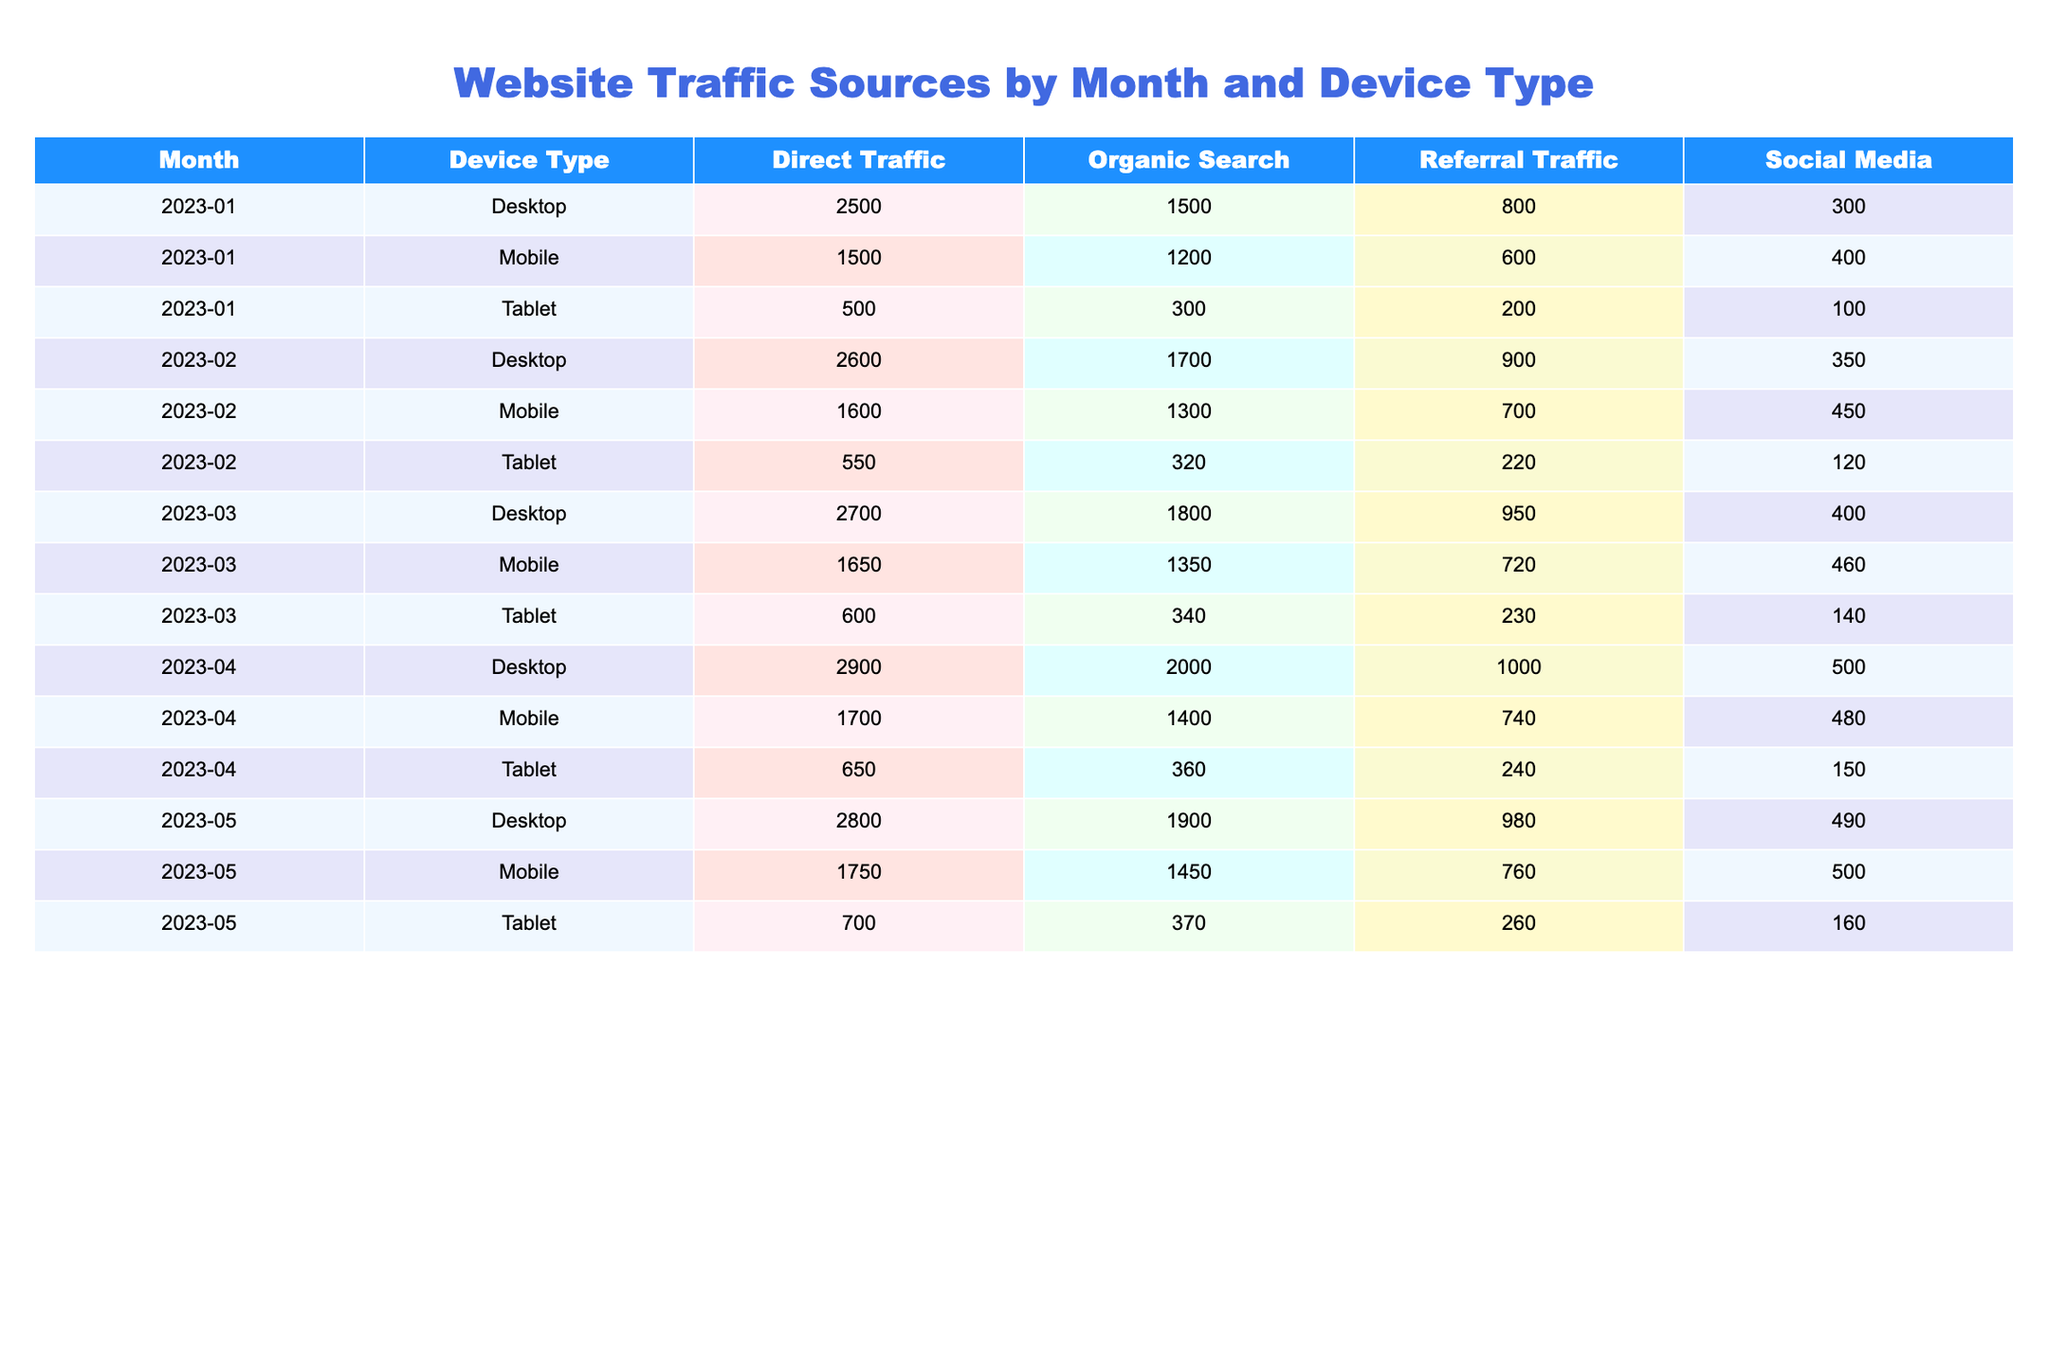What was the total organic search traffic for mobile devices in January 2023? In January 2023, the organic search traffic for mobile devices was 1200. Therefore, the total organic search traffic for mobile devices in that month is directly found in the table.
Answer: 1200 What is the difference in direct traffic between tablets and desktops for March 2023? For March 2023, the direct traffic for tablets is 600 and for desktops, it is 2700. The difference is calculated by subtracting the tablet traffic from the desktop traffic: 2700 - 600 = 2100.
Answer: 2100 Is the referral traffic higher for mobile devices compared to desktop devices in April 2023? In April 2023, the referral traffic for mobile devices is 740, while for desktops, it is 1000. Since 740 is less than 1000, the statement is false.
Answer: No What month had the highest tablet traffic overall and what was the total? To find the month with the highest tablet traffic, look at the tablet values for each month: January (100), February (120), March (140), April (150), and May (160). The highest is in May with a total of 160 for tablet traffic.
Answer: May, 160 What is the average traffic from social media for desktop devices over the five months? To calculate the average social media traffic for desktop devices, sum the social media values for each month: 300 (Jan) + 350 (Feb) + 400 (Mar) + 500 (Apr) + 490 (May) = 2290. There are 5 months, so the average is 2290 / 5 = 458.
Answer: 458 Which device type had the least amount of organic search traffic in April 2023? In April 2023, the organic search traffic for desktop is 2000, for mobile is 1400, and for tablet is 360. The lowest is for the tablet with 360.
Answer: Tablet What was the trend in direct traffic from January to May 2023 for mobile devices? Reviewing the direct traffic for mobile devices: January (1500), February (1600), March (1650), April (1700), and May (1750). Each month shows an increase from the previous month, indicating a positive trend in direct traffic for mobile devices.
Answer: Increasing In which month and device type was the total traffic from all sources the highest? By calculating total traffic for each combination, we find Desktop in April 2023 has the highest total: 2900 (Direct) + 2000 (Organic) + 1000 (Referral) + 500 (Social) = 6400. Thus, the highest total is in April for Desktop devices.
Answer: April, Desktop 